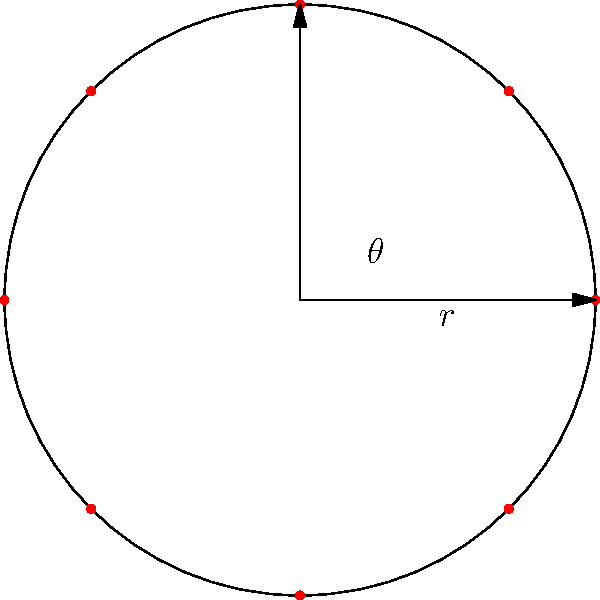You want to plant 8 different herbs in a circular garden with a radius of 5 meters. To ensure even spacing, you decide to use polar coordinates. What should be the angle $\theta$ (in radians) between each plant to achieve equal spacing around the circle? To find the angle between each plant for even spacing, follow these steps:

1. Recognize that the plants will form a regular octagon inscribed in the circle, as there are 8 herbs.

2. Recall that a full circle contains $2\pi$ radians.

3. To space 8 plants evenly, we need to divide the full circle into 8 equal parts:

   $$\theta = \frac{2\pi}{8}$$

4. Simplify the fraction:

   $$\theta = \frac{\pi}{4}$$

This angle, $\frac{\pi}{4}$ radians, is equivalent to 45 degrees and will ensure equal spacing between all 8 herbs in your circular garden.
Answer: $\frac{\pi}{4}$ radians 